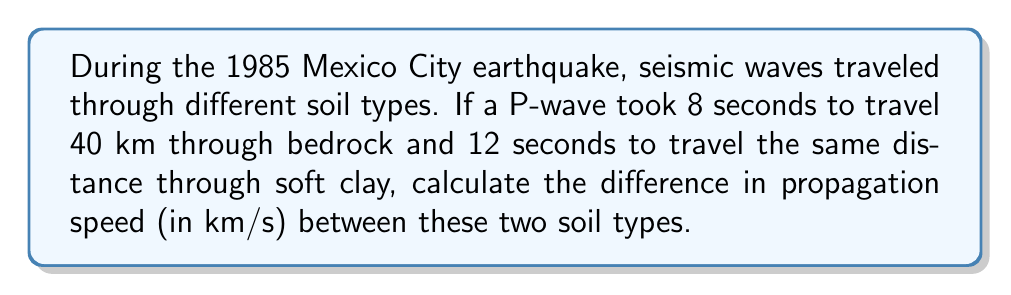Show me your answer to this math problem. Let's approach this step-by-step:

1) First, recall the formula for speed:
   $$ \text{Speed} = \frac{\text{Distance}}{\text{Time}} $$

2) For the bedrock:
   Distance = 40 km
   Time = 8 seconds
   $$ \text{Speed}_{\text{bedrock}} = \frac{40 \text{ km}}{8 \text{ s}} = 5 \text{ km/s} $$

3) For the soft clay:
   Distance = 40 km
   Time = 12 seconds
   $$ \text{Speed}_{\text{clay}} = \frac{40 \text{ km}}{12 \text{ s}} = \frac{10}{3} \text{ km/s} $$

4) To find the difference in propagation speed:
   $$ \text{Difference} = \text{Speed}_{\text{bedrock}} - \text{Speed}_{\text{clay}} $$
   $$ = 5 \text{ km/s} - \frac{10}{3} \text{ km/s} $$
   $$ = \frac{15}{3} \text{ km/s} - \frac{10}{3} \text{ km/s} $$
   $$ = \frac{5}{3} \text{ km/s} $$
   $$ \approx 1.67 \text{ km/s} $$
Answer: $\frac{5}{3}$ km/s or approximately 1.67 km/s 